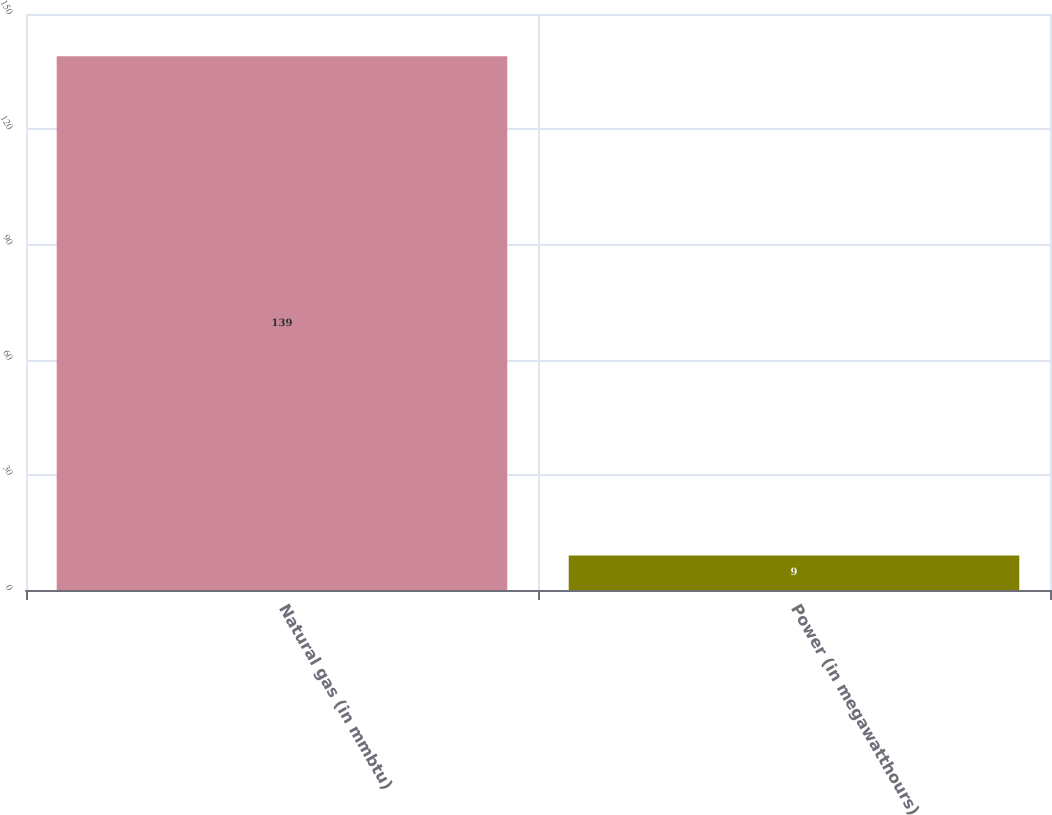Convert chart to OTSL. <chart><loc_0><loc_0><loc_500><loc_500><bar_chart><fcel>Natural gas (in mmbtu)<fcel>Power (in megawatthours)<nl><fcel>139<fcel>9<nl></chart> 